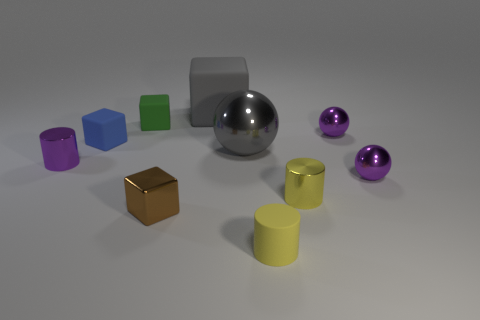Subtract all big gray matte cubes. How many cubes are left? 3 Subtract all gray cubes. How many cubes are left? 3 Subtract all cubes. How many objects are left? 6 Subtract 1 balls. How many balls are left? 2 Subtract all blue cylinders. Subtract all yellow balls. How many cylinders are left? 3 Subtract all cyan cubes. How many brown balls are left? 0 Subtract all brown things. Subtract all small purple metal cylinders. How many objects are left? 8 Add 8 yellow cylinders. How many yellow cylinders are left? 10 Add 6 tiny brown rubber things. How many tiny brown rubber things exist? 6 Subtract 0 red cubes. How many objects are left? 10 